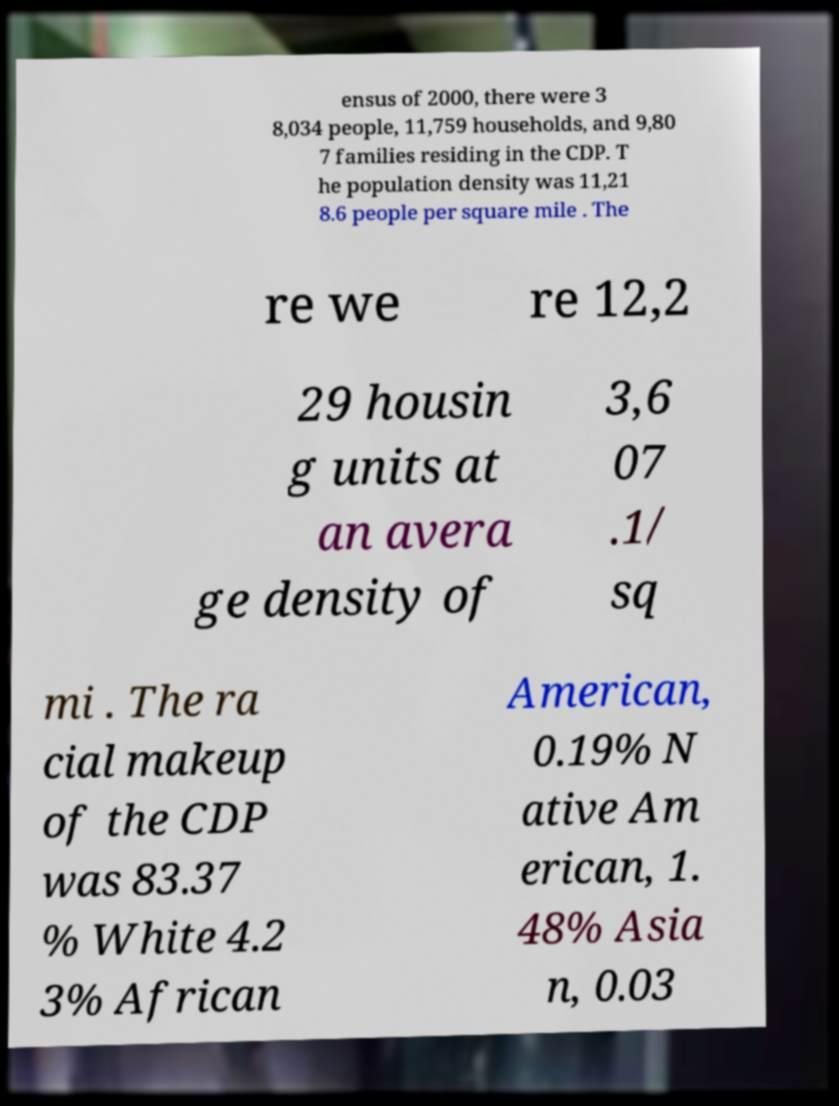Could you assist in decoding the text presented in this image and type it out clearly? ensus of 2000, there were 3 8,034 people, 11,759 households, and 9,80 7 families residing in the CDP. T he population density was 11,21 8.6 people per square mile . The re we re 12,2 29 housin g units at an avera ge density of 3,6 07 .1/ sq mi . The ra cial makeup of the CDP was 83.37 % White 4.2 3% African American, 0.19% N ative Am erican, 1. 48% Asia n, 0.03 